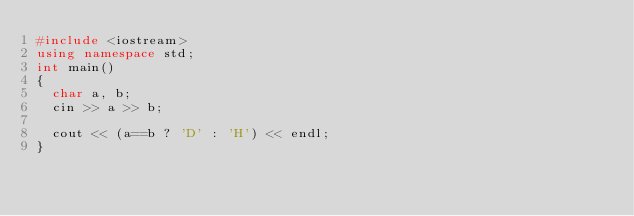Convert code to text. <code><loc_0><loc_0><loc_500><loc_500><_C++_>#include <iostream>
using namespace std;
int main()
{
  char a, b;
  cin >> a >> b;

  cout << (a==b ? 'D' : 'H') << endl;
}
</code> 